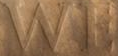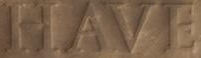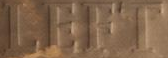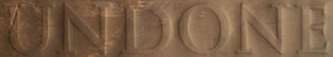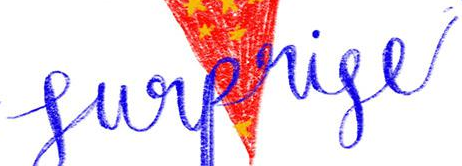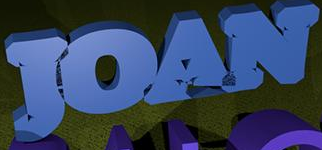What text is displayed in these images sequentially, separated by a semicolon? WE; HAVE; LEFT; UNDONE; Surprise; JOAN 